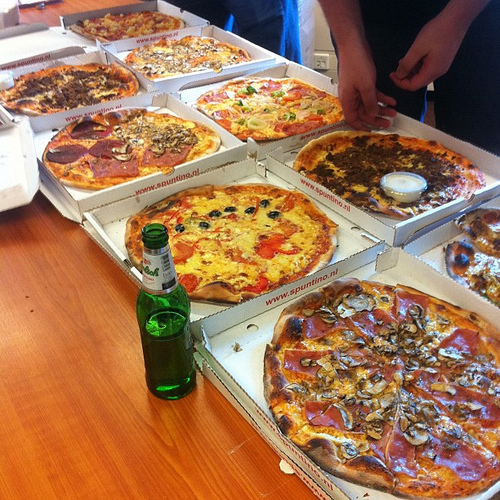Which side of the image is the pepperoni on? The pepperoni is on the right side of the image. 